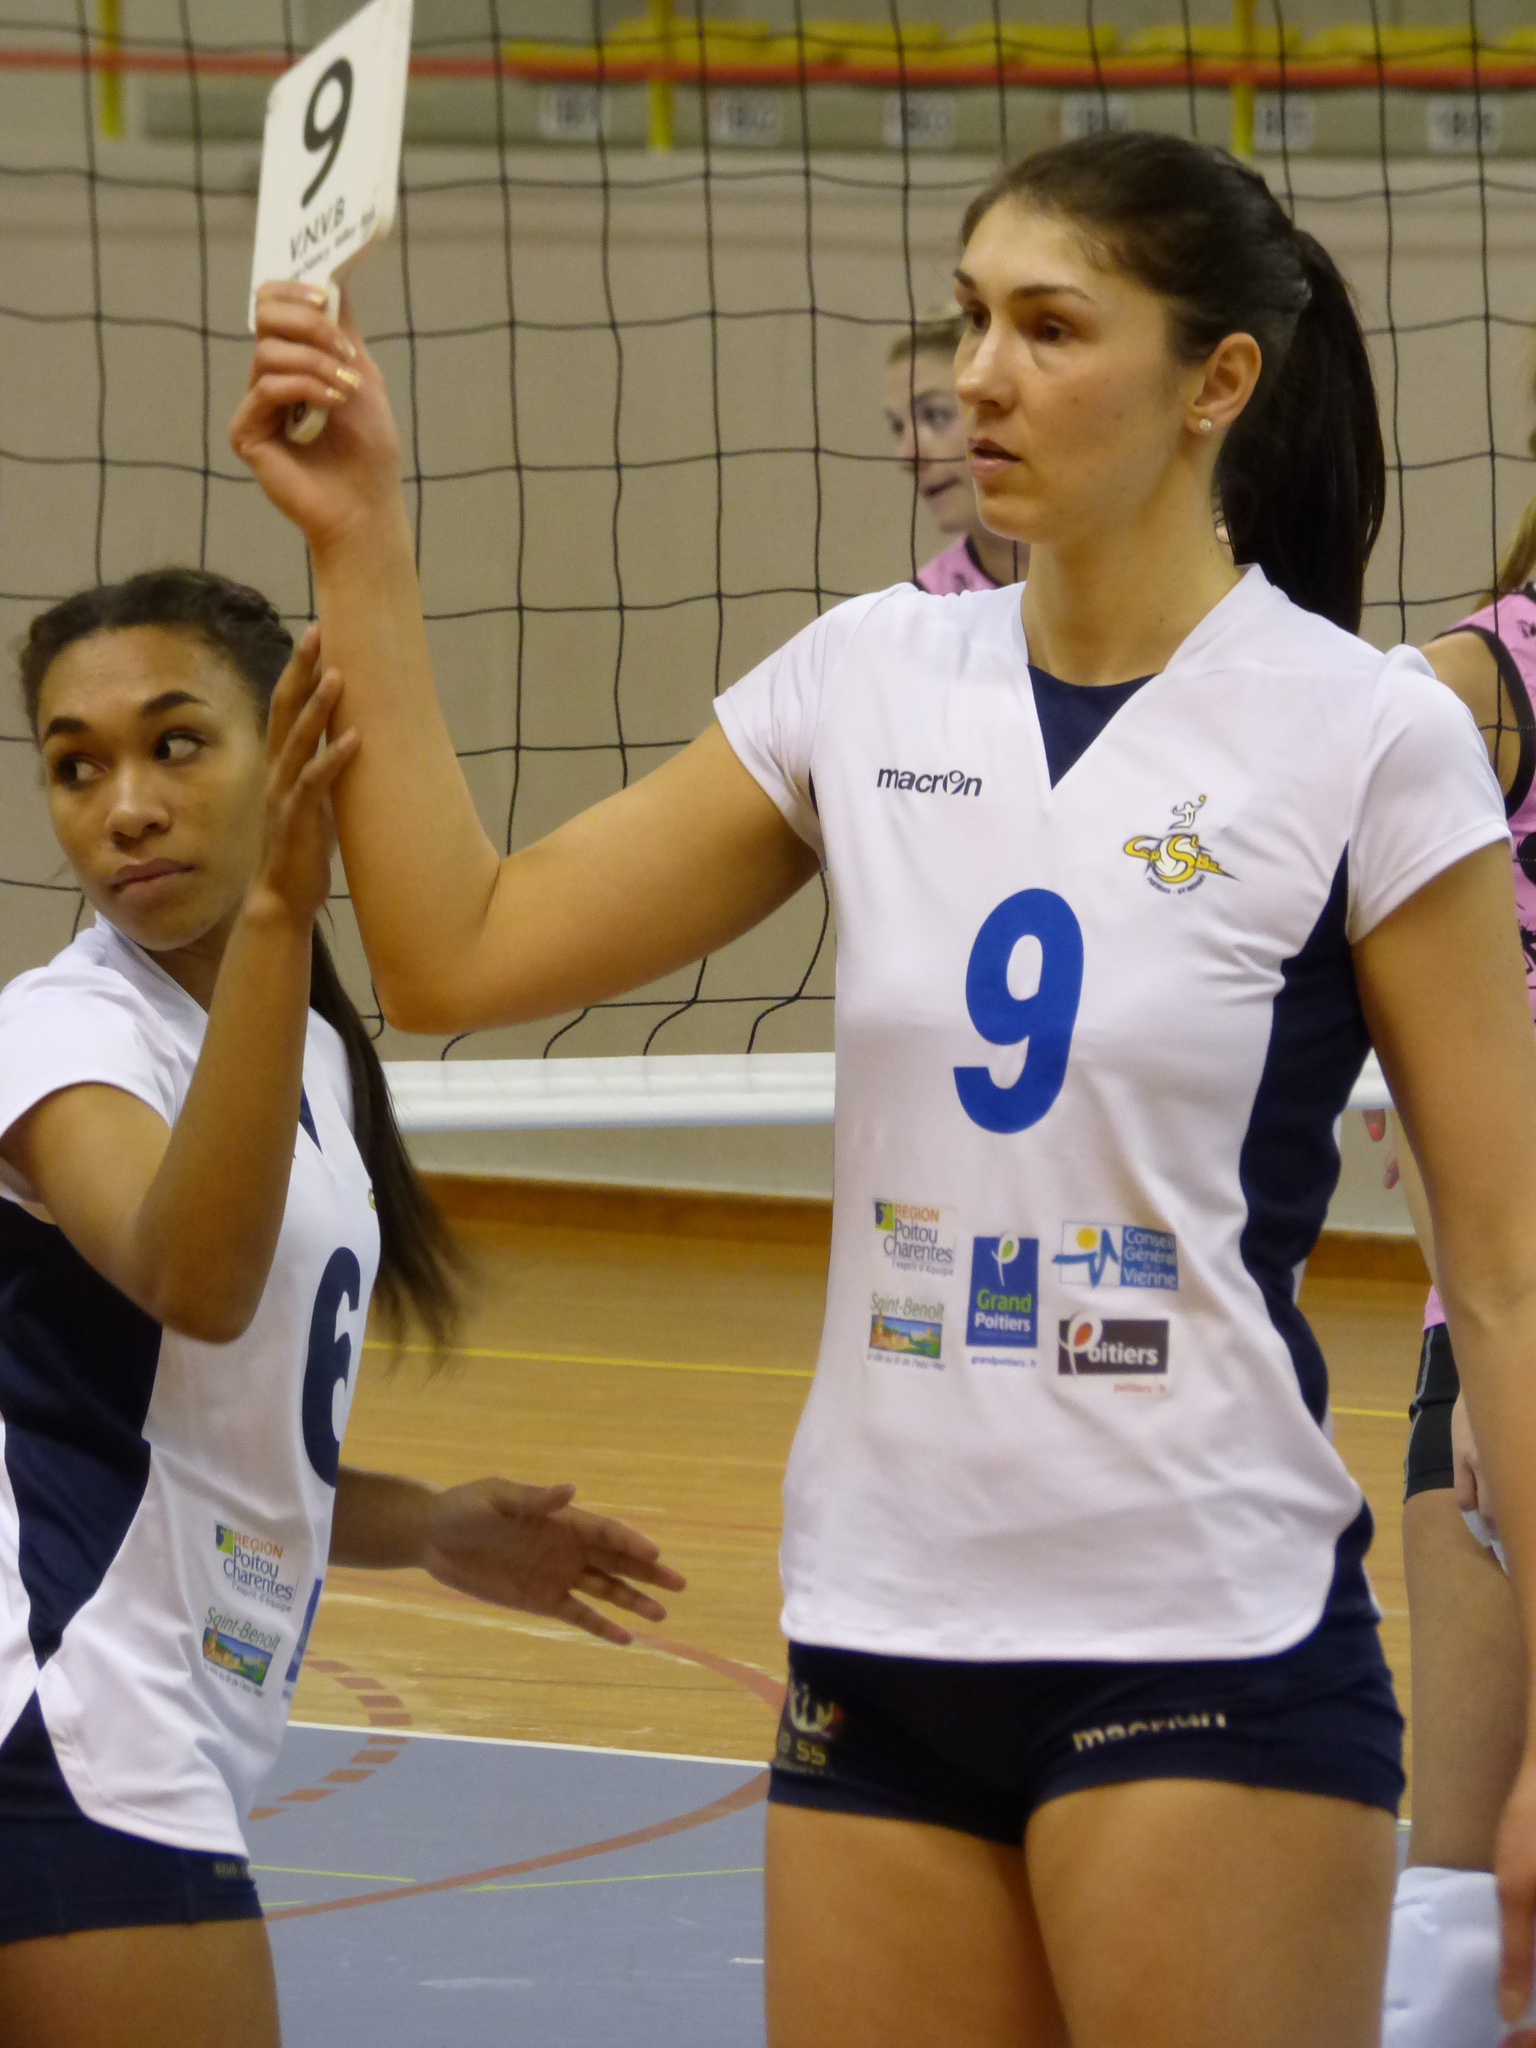Provide a one-sentence caption for the provided image. Player number 9 holds up a card that also has the number 9 on it. 